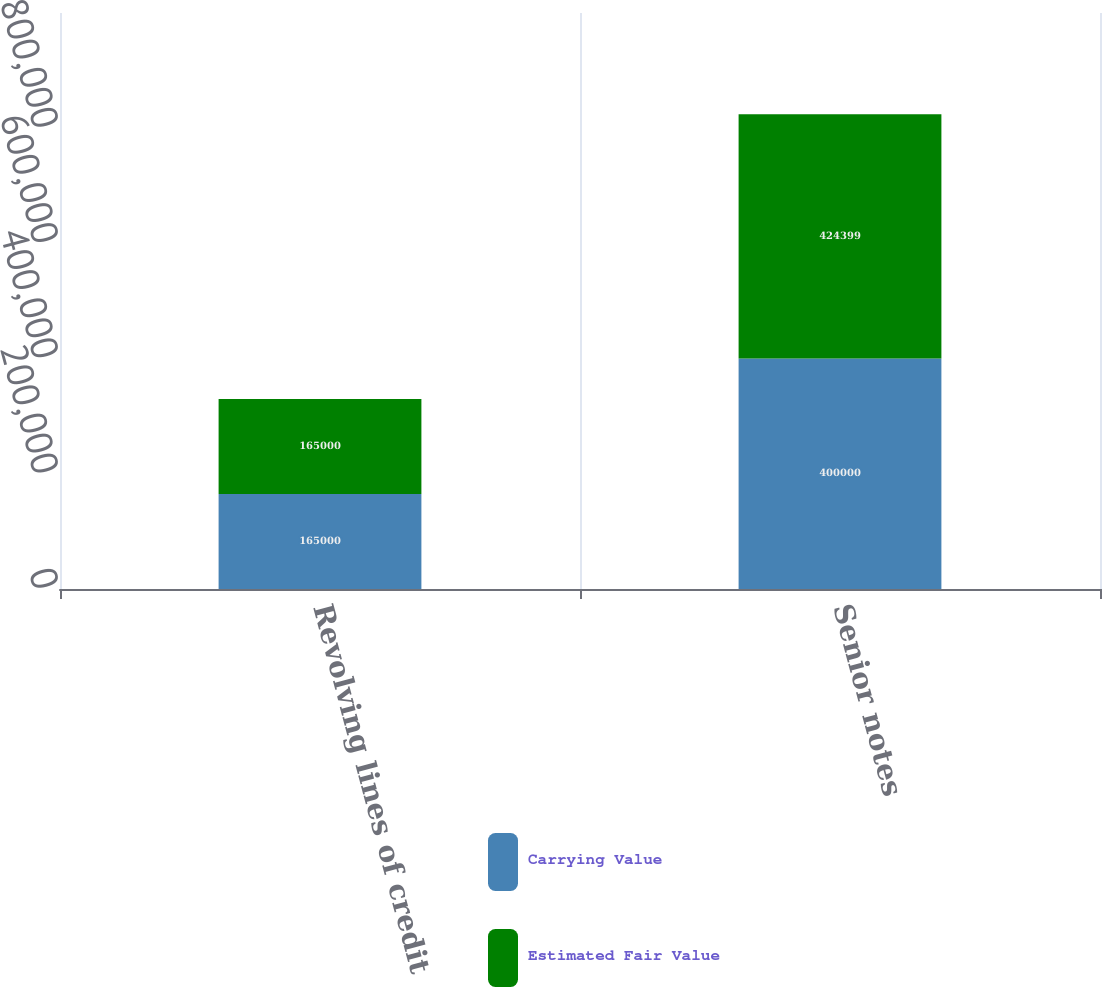Convert chart to OTSL. <chart><loc_0><loc_0><loc_500><loc_500><stacked_bar_chart><ecel><fcel>Revolving lines of credit<fcel>Senior notes<nl><fcel>Carrying Value<fcel>165000<fcel>400000<nl><fcel>Estimated Fair Value<fcel>165000<fcel>424399<nl></chart> 